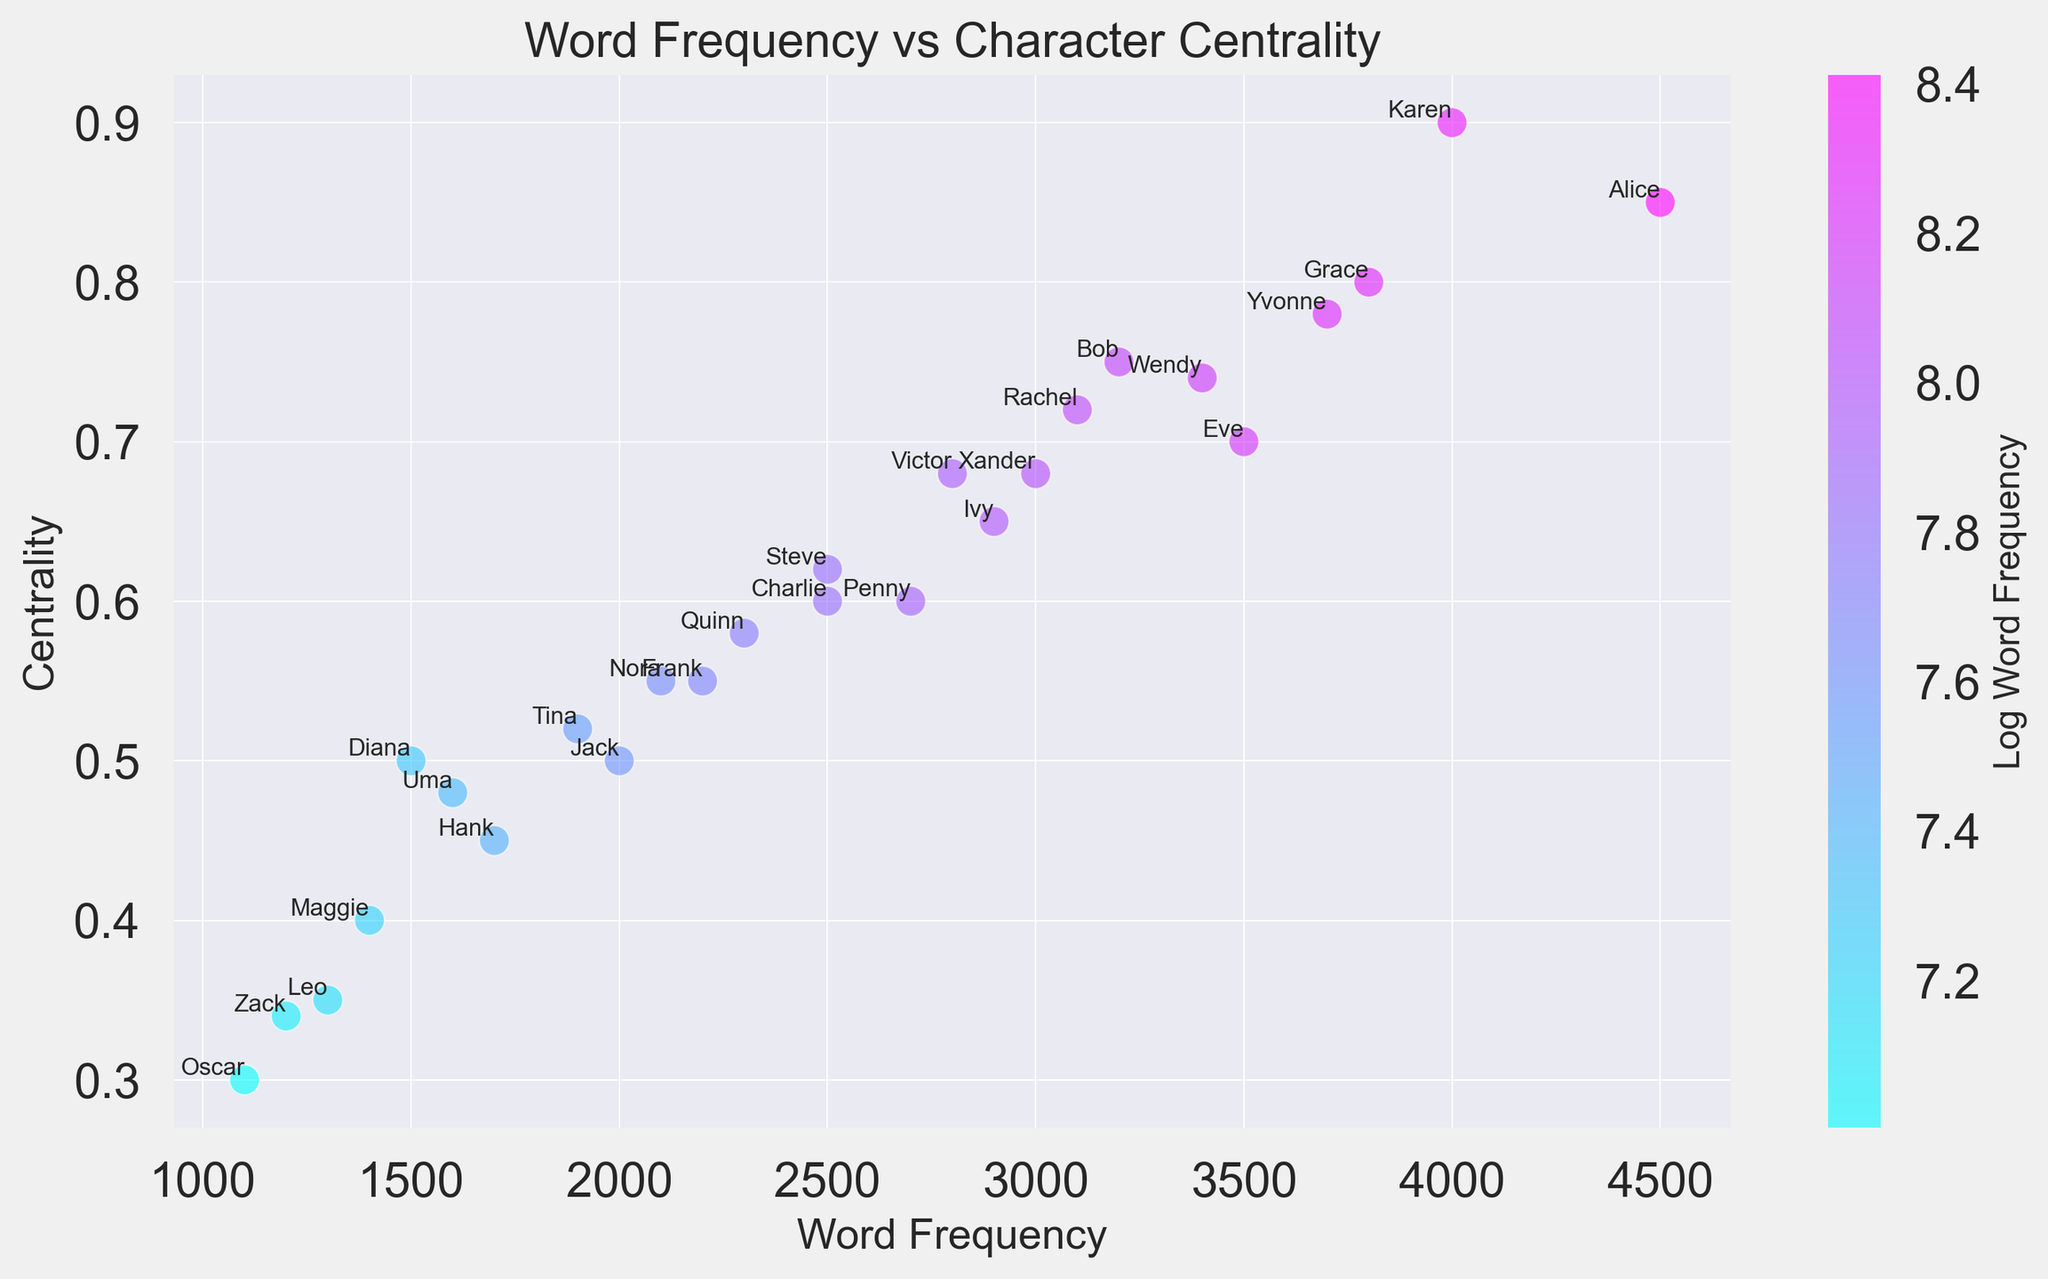Who has the highest word frequency? Look at the x-axis (Word Frequency) to find the character with the largest value. "Alice" has the highest word frequency.
Answer: Alice Who has the highest centrality? Look at the y-axis (Centrality) to find the character with the largest value. "Karen" has the highest centrality.
Answer: Karen Which character has a centrality of 0.68 and what is their word frequency? Find the points on the y-axis at 0.68 and check which character they represent. "Victor" and "Xander" have a centrality of 0.68. Look at their Word Frequency on the x-axis. Victor has 2800 and Xander has 3000.
Answer: Victor: 2800; Xander: 3000 Compare the centrality of Frank and Nora. Who is more central? Identify Frank and Nora on the plot and compare their y-values (Centrality). Frank has a centrality of 0.55 while Nora also has 0.55. They have equal centrality.
Answer: Equal centrality What is the relationship between word frequency and centrality in the figure? Observe the trend in the scatter plot. As word frequency increases on the x-axis, pay attention to how the centrality tends to behave on the y-axis. There seems to be a general positive correlation.
Answer: Positive correlation Which character is closest to the average word frequency? Calculate the average of the word frequencies, then find the character whose word frequency is nearest to this average value. The average is calculated as (sum of all word frequencies) / 26 characters = 71800 / 26 = 2769. The closest value is "Penny" with a word frequency of 2700.
Answer: Penny What color represents higher word frequencies in the plot? Observe the color gradient represented by the color bar. Higher word frequencies are indicated by colors towards the darker end of the spectrum (more cool colors like dark blue).
Answer: Dark blue Find the characters with centrality between 0.7 and 0.8. Observe the y-axis for points between 0.7 and 0.8 and list those characters. "Eve," "Rachel," "Wendy," and "Yvonne" have centrality values in this range.
Answer: Eve, Rachel, Wendy, Yvonne Compare the word frequency of Grace and Diana. Who uses more words? Identify the word frequency (x-axis) for Grace and Diana. Grace has 3800 words while Diana has 1500. Grace uses more words.
Answer: Grace Is there any character with a centrality of less than 0.4? If so, who are they? Look at the y-axis and find any points below 0.4. Identify the characters associated with these points. "Leo" with 0.35 and "Zack" with 0.34 have centrality values less than 0.4.
Answer: Leo, Zack 